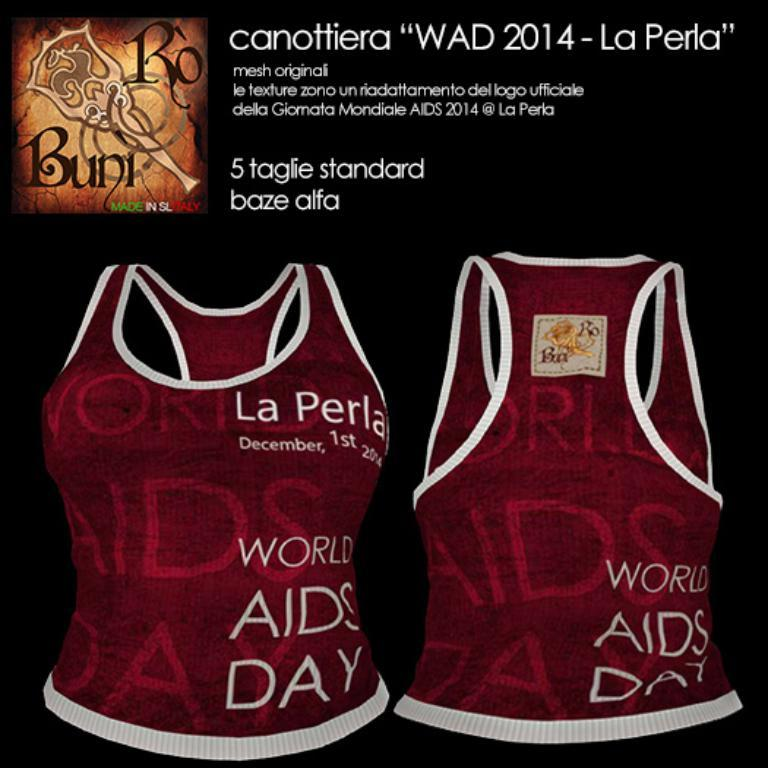<image>
Offer a succinct explanation of the picture presented. two red and white jersays for world aids day on december 1st 2014 